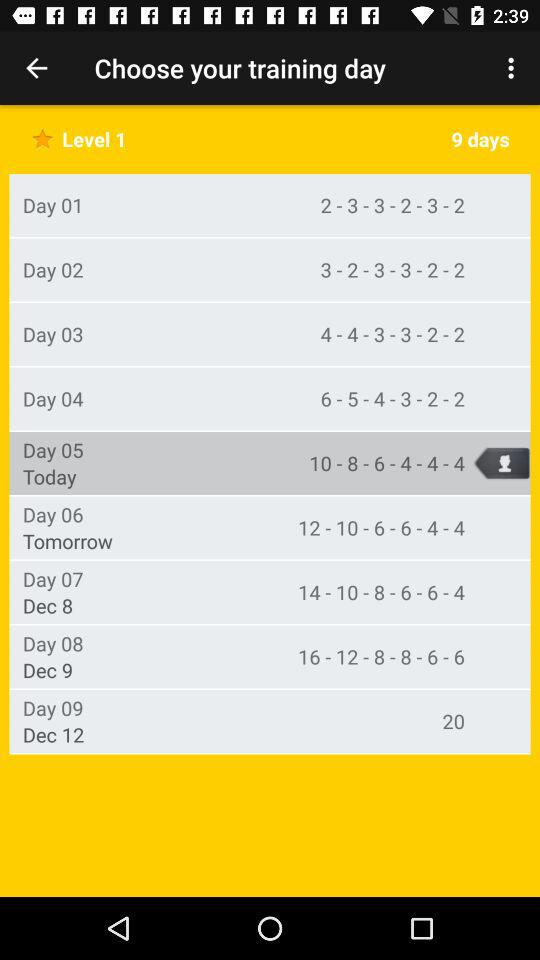Which day is selected? The selected day is "Day 05". 